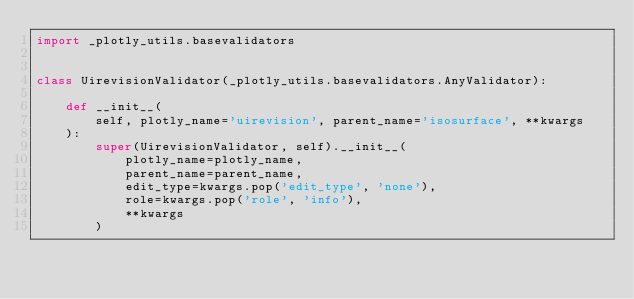Convert code to text. <code><loc_0><loc_0><loc_500><loc_500><_Python_>import _plotly_utils.basevalidators


class UirevisionValidator(_plotly_utils.basevalidators.AnyValidator):

    def __init__(
        self, plotly_name='uirevision', parent_name='isosurface', **kwargs
    ):
        super(UirevisionValidator, self).__init__(
            plotly_name=plotly_name,
            parent_name=parent_name,
            edit_type=kwargs.pop('edit_type', 'none'),
            role=kwargs.pop('role', 'info'),
            **kwargs
        )
</code> 